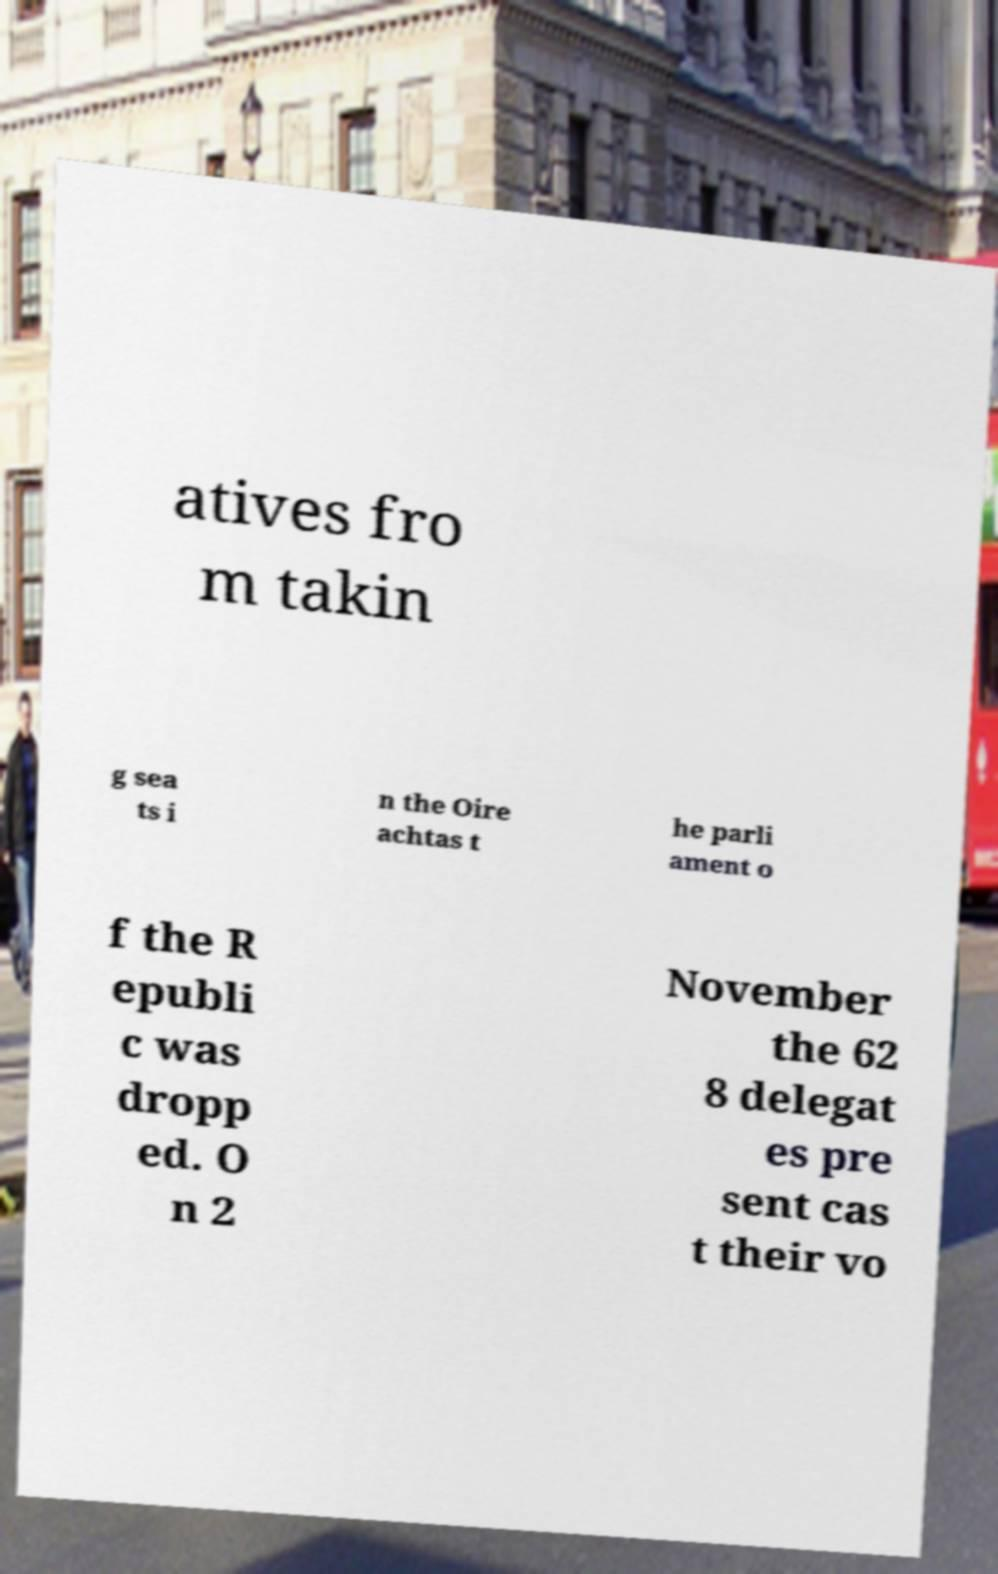I need the written content from this picture converted into text. Can you do that? atives fro m takin g sea ts i n the Oire achtas t he parli ament o f the R epubli c was dropp ed. O n 2 November the 62 8 delegat es pre sent cas t their vo 